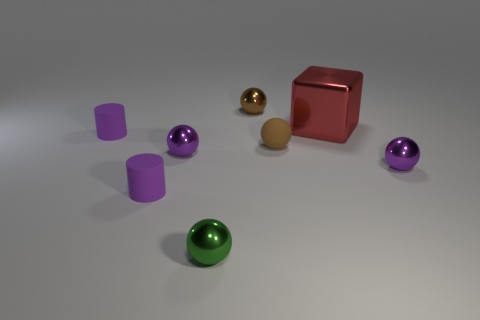There is a green thing that is the same material as the red thing; what is its size?
Ensure brevity in your answer.  Small. What number of cubes are either blue shiny objects or tiny green metal things?
Your response must be concise. 0. Is the number of matte cylinders greater than the number of small gray cylinders?
Offer a terse response. Yes. How many brown rubber things have the same size as the brown shiny object?
Make the answer very short. 1. What is the shape of the shiny object that is the same color as the matte ball?
Make the answer very short. Sphere. What number of objects are either purple metallic objects on the right side of the brown rubber sphere or tiny purple shiny spheres?
Your response must be concise. 2. Is the number of brown cubes less than the number of purple metal things?
Offer a terse response. Yes. What is the shape of the large object that is made of the same material as the small green sphere?
Offer a terse response. Cube. Are there any small matte balls on the left side of the brown metal thing?
Your answer should be compact. No. Are there fewer big shiny objects to the left of the red block than brown matte things?
Provide a short and direct response. Yes. 